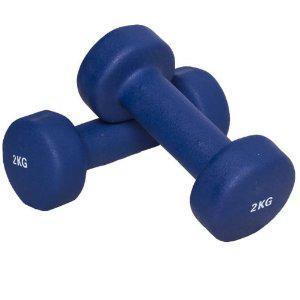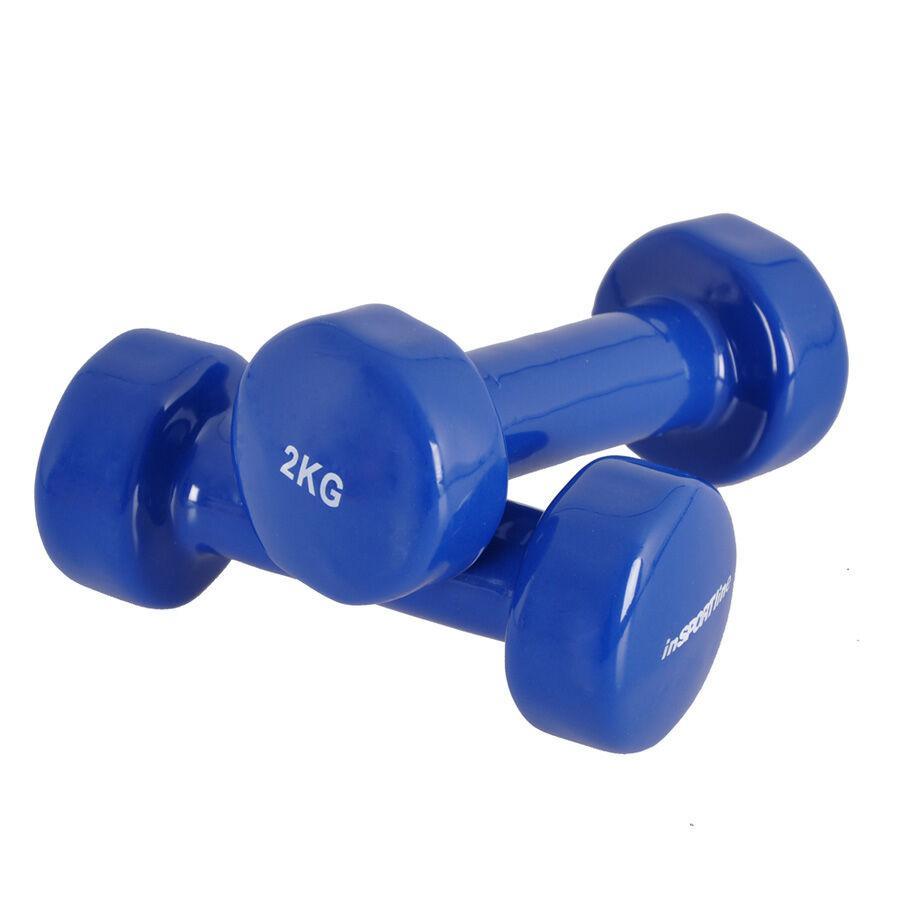The first image is the image on the left, the second image is the image on the right. For the images shown, is this caption "Each image shows two dumbbells, and right and left images show the same color weights." true? Answer yes or no. Yes. The first image is the image on the left, the second image is the image on the right. Assess this claim about the two images: "The pair of dumbells in the left image is the same color as the pair of dumbells in the right image.". Correct or not? Answer yes or no. Yes. 